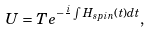Convert formula to latex. <formula><loc_0><loc_0><loc_500><loc_500>U = T e ^ { - \frac { i } { } \int H _ { s p i n } ( t ) d t } ,</formula> 